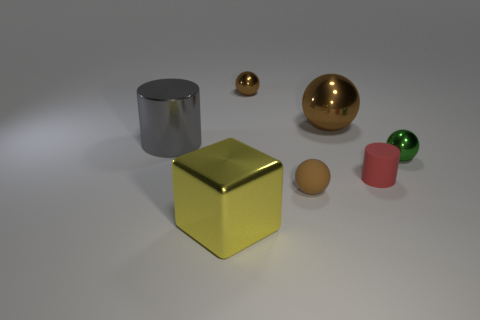What material is the brown object that is the same size as the brown matte ball?
Make the answer very short. Metal. Does the small brown thing that is behind the metal cylinder have the same shape as the big brown metal thing?
Your answer should be compact. Yes. Are there more tiny matte cylinders behind the shiny cylinder than green spheres in front of the brown matte thing?
Your answer should be compact. No. What number of blocks have the same material as the green ball?
Offer a terse response. 1. Does the gray shiny thing have the same size as the brown matte sphere?
Ensure brevity in your answer.  No. The large metal ball has what color?
Offer a very short reply. Brown. How many things are either small red matte cylinders or small green things?
Give a very brief answer. 2. Is there a large brown object that has the same shape as the small brown metal object?
Give a very brief answer. Yes. There is a tiny rubber object that is on the left side of the big brown metallic ball; is its color the same as the tiny rubber cylinder?
Your answer should be very brief. No. What shape is the tiny metal thing behind the small object right of the tiny rubber cylinder?
Your answer should be very brief. Sphere. 